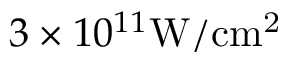<formula> <loc_0><loc_0><loc_500><loc_500>3 \times 1 0 ^ { 1 1 } { W / c m ^ { 2 } }</formula> 